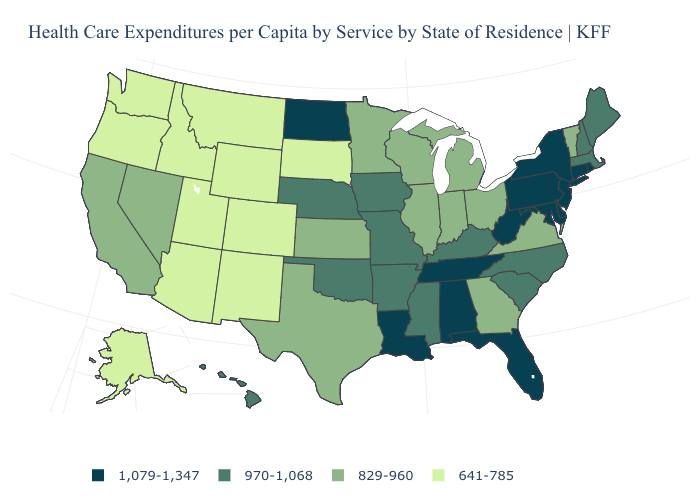What is the lowest value in the USA?
Quick response, please. 641-785. Is the legend a continuous bar?
Be succinct. No. What is the highest value in the West ?
Be succinct. 970-1,068. Does Missouri have a lower value than Delaware?
Write a very short answer. Yes. What is the value of Missouri?
Give a very brief answer. 970-1,068. Which states have the highest value in the USA?
Keep it brief. Alabama, Connecticut, Delaware, Florida, Louisiana, Maryland, New Jersey, New York, North Dakota, Pennsylvania, Rhode Island, Tennessee, West Virginia. Does Utah have the lowest value in the USA?
Write a very short answer. Yes. What is the highest value in the USA?
Short answer required. 1,079-1,347. What is the highest value in states that border Oregon?
Answer briefly. 829-960. What is the value of North Dakota?
Quick response, please. 1,079-1,347. Name the states that have a value in the range 641-785?
Keep it brief. Alaska, Arizona, Colorado, Idaho, Montana, New Mexico, Oregon, South Dakota, Utah, Washington, Wyoming. Name the states that have a value in the range 641-785?
Answer briefly. Alaska, Arizona, Colorado, Idaho, Montana, New Mexico, Oregon, South Dakota, Utah, Washington, Wyoming. Is the legend a continuous bar?
Concise answer only. No. What is the lowest value in states that border Connecticut?
Quick response, please. 970-1,068. Does the first symbol in the legend represent the smallest category?
Quick response, please. No. 